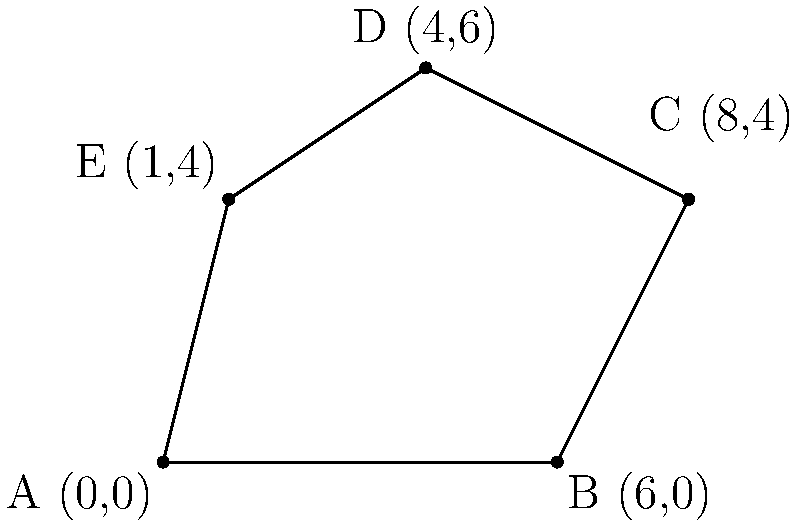As an agricultural biologist, you're tasked with calculating the area of an irregularly shaped field for a crop yield study. The field's boundaries are defined by the following coordinate points: A(0,0), B(6,0), C(8,4), D(4,6), and E(1,4). Using the shoelace formula, calculate the area of this field in square units. Round your answer to two decimal places. To calculate the area of an irregularly shaped field using coordinate points, we can use the shoelace formula (also known as the surveyor's formula). The steps are as follows:

1) The shoelace formula for a polygon with vertices $(x_1, y_1), (x_2, y_2), ..., (x_n, y_n)$ is:

   Area = $\frac{1}{2}|((x_1y_2 + x_2y_3 + ... + x_ny_1) - (y_1x_2 + y_2x_3 + ... + y_nx_1))|$

2) For our field, we have:
   A(0,0), B(6,0), C(8,4), D(4,6), E(1,4)

3) Let's apply the formula:

   $\frac{1}{2}|((0 \cdot 0 + 6 \cdot 4 + 8 \cdot 6 + 4 \cdot 4 + 1 \cdot 0) - (0 \cdot 6 + 0 \cdot 8 + 4 \cdot 4 + 6 \cdot 1 + 4 \cdot 0))|$

4) Simplify:
   $\frac{1}{2}|((0 + 24 + 48 + 16 + 0) - (0 + 0 + 16 + 6 + 0))|$
   $\frac{1}{2}|(88 - 22)|$
   $\frac{1}{2}|(66)|$

5) Calculate:
   $\frac{66}{2} = 33$

Therefore, the area of the field is 33 square units.
Answer: 33 square units 